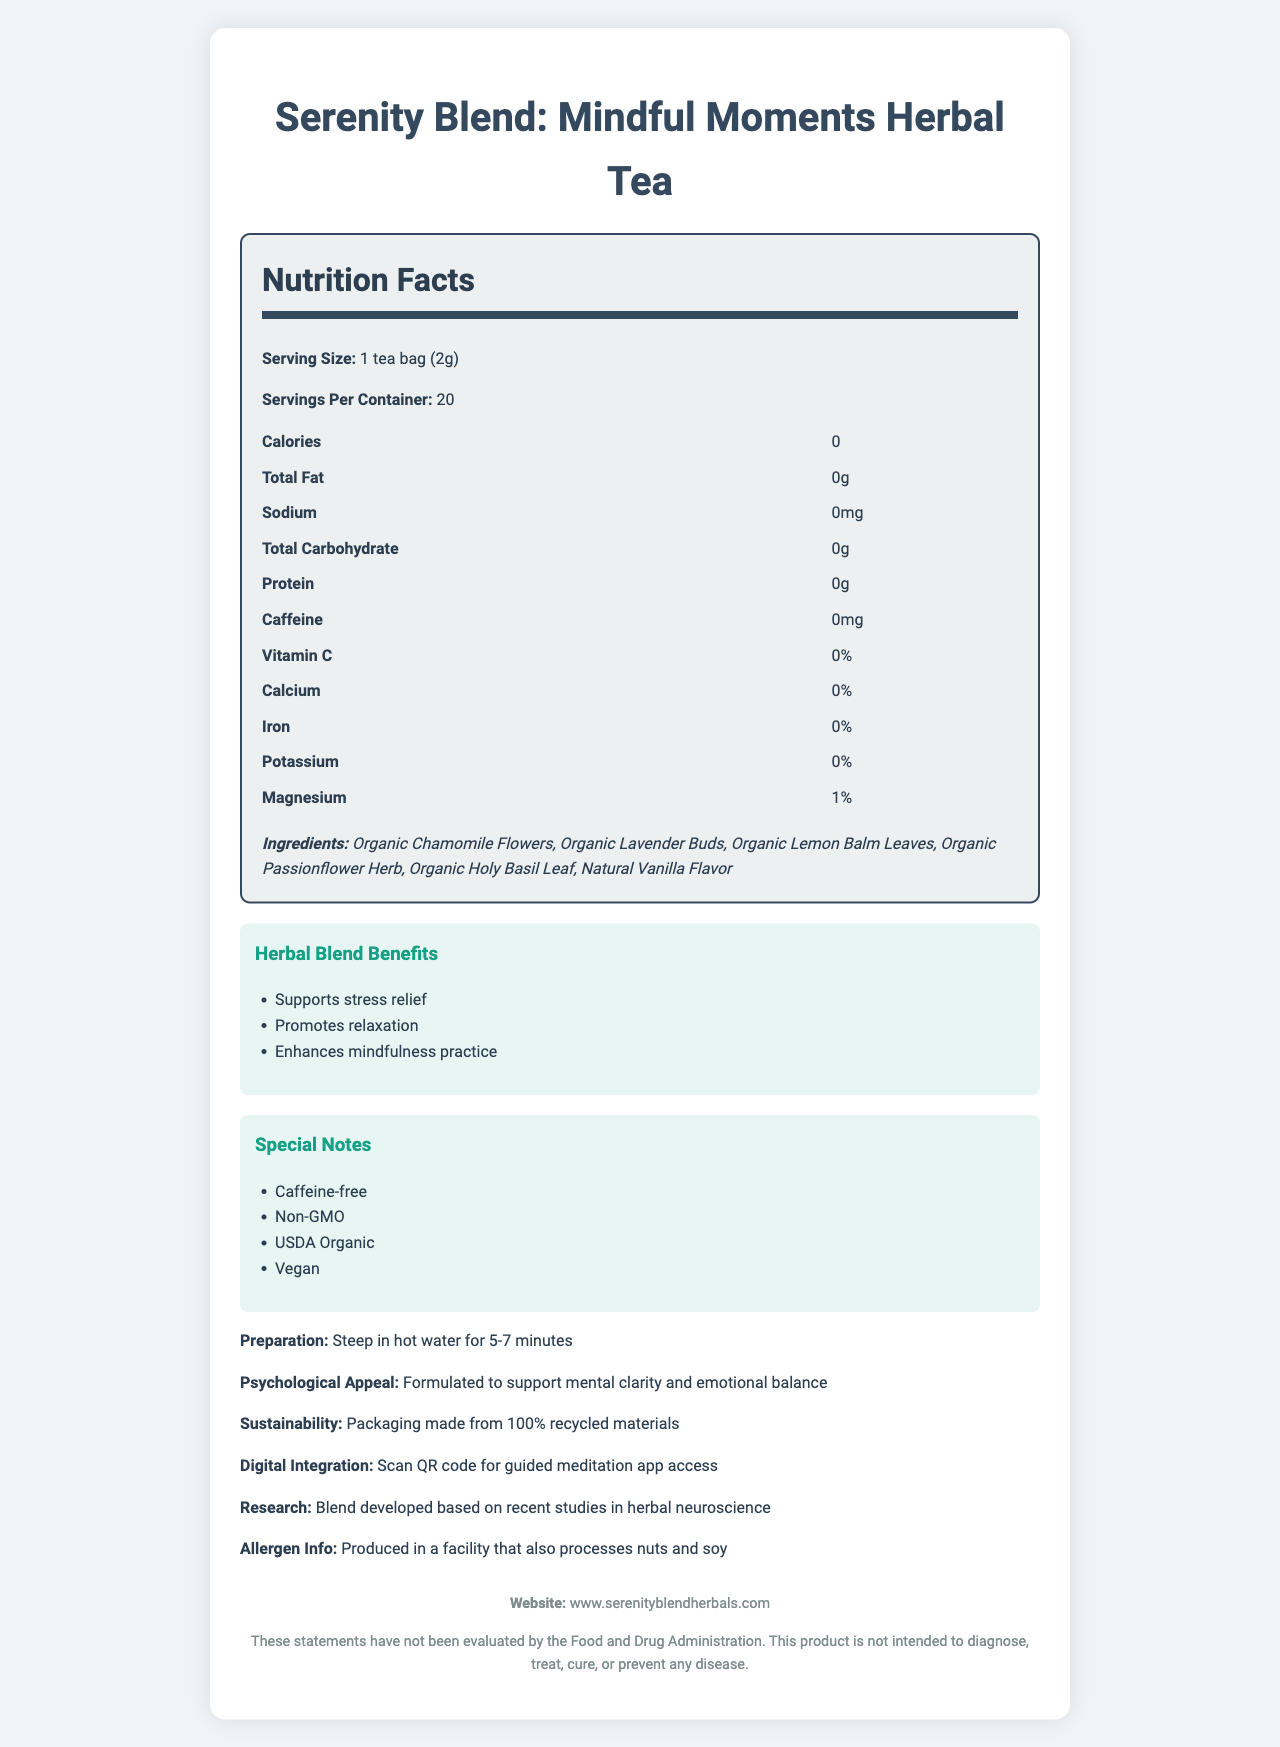what is the serving size of Serenity Blend tea? The serving size is listed as "1 tea bag (2g)" in the Nutrition Facts section of the document.
Answer: 1 tea bag (2g) how many servings are there per container? The Nutrition Facts section mentions that there are "20" servings per container.
Answer: 20 what is the sodium content per serving? The sodium content per serving is listed as "0mg" in the Nutrition Facts section.
Answer: 0mg what are the ingredients of Serenity Blend tea? The ingredients are listed under the Ingredients section as "Organic Chamomile Flowers, Organic Lavender Buds, Organic Lemon Balm Leaves, Organic Passionflower Herb, Organic Holy Basil Leaf, Natural Vanilla Flavor."
Answer: Organic Chamomile Flowers, Organic Lavender Buds, Organic Lemon Balm Leaves, Organic Passionflower Herb, Organic Holy Basil Leaf, Natural Vanilla Flavor what is the preparation method for the tea? The preparation method is stated as "Steep in hot water for 5-7 minutes."
Answer: Steep in hot water for 5-7 minutes what percentage of calcium is in each serving? The Nutrition Facts section indicates the calcium content is "0%."
Answer: 0% what are the special notes about Serenity Blend tea? A. Caffeine-free, USDA Organic B. Non-GMO, Contains caffeine C. Vegan, Contains caffeine D. USDA Organic, Not Vegan The special notes section lists "Caffeine-free" and "USDA Organic" as key features of the tea.
Answer: A. Caffeine-free, USDA Organic which one of the following is a benefit of the herbal blend? i. Supports stress relief ii. Lowers blood sugar iii. Increases muscle mass "Supports stress relief" is specifically mentioned under the Herbal Blend Benefits section, whereas the other options are not listed.
Answer: i. Supports stress relief is the Serenity Blend tea suitable for vegans? The special notes section includes "Vegan," indicating that the tea is suitable for vegans.
Answer: Yes describe the main idea of the document. The document lists the tea's serving size, serving per container, nutritional values, ingredients, herbal blend benefits, special notes, preparation instructions, psychological appeal, sustainability efforts, allergen information, and a QR code for a related guided meditation app.
Answer: The document provides information about Serenity Blend: Mindful Moments Herbal Tea, including its nutrition facts, ingredients, benefits, preparation method, special features, and additional notes regarding its support for mental clarity and emotional balance. It emphasizes the tea's organic ingredients, caffeine-free nature, and suitability for mindfulness and relaxation practices. what is the tea brand's website? The footer section of the document provides the website as "www.serenityblendherbals.com."
Answer: www.serenityblendherbals.com how much magnesium is in each serving? The Nutrition Facts section shows magnesium content as "1%."
Answer: 1% what research backs the herbal blend? The document mentions that the blend is "developed based on recent studies in herbal neuroscience."
Answer: Blend developed based on recent studies in herbal neuroscience what is the digital integration feature of the tea? The digital integration feature mentioned is "Scan QR code for guided meditation app access."
Answer: Scan QR code for guided meditation app access how does the packaging support sustainability? The sustainability section states that the packaging is made from "100% recycled materials."
Answer: Packaging made from 100% recycled materials what components of the tea support emotional balance? Although not explicitly listed as supporting emotional balance in the same section, these are the ingredients of the tea which is claimed to support mental clarity and emotional balance in the psychological appeal section.
Answer: Organic Chamomile Flowers, Organic Lavender Buds, Organic Lemon Balm Leaves, Organic Passionflower Herb, Organic Holy Basil Leaf, Natural Vanilla Flavor what scientific studies support the effectiveness of the Serenity Blend tea? The document mentions that the blend is based on "recent studies in herbal neuroscience," but it does not provide specific details or citations of these studies.
Answer: Cannot be determined 